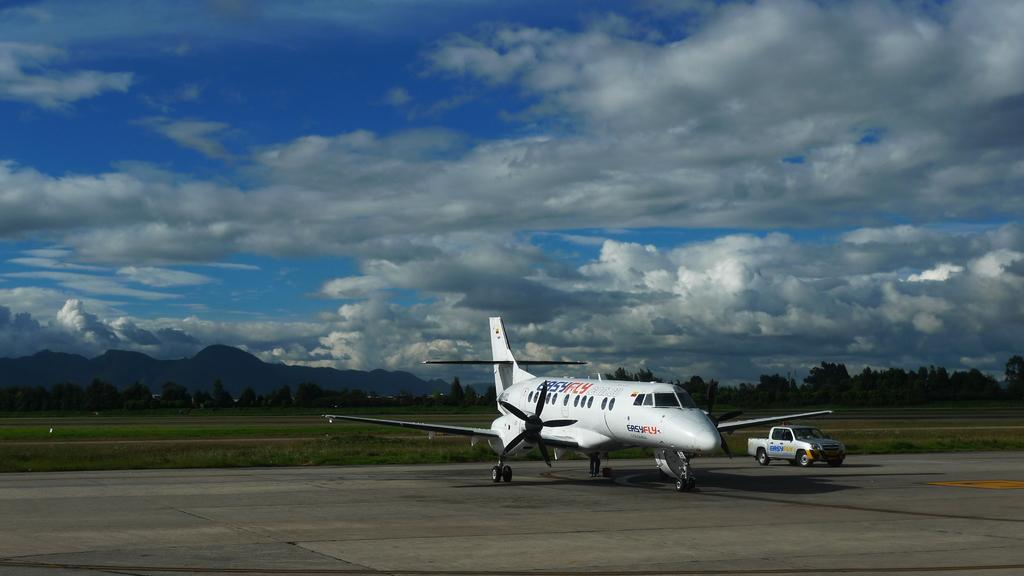What is the main subject of the image? The main subject of the image is an airplane. What other vehicle can be seen in the image? There is a jeep in the image. What can be seen in the background of the image? In the background of the image, there is a field, trees, a mountain, and a cloudy sky. Where is the market located in the image? There is no market present in the image. What type of work is being done in the image? The image does not depict any work being done; it features an airplane and a jeep in a natural setting. 